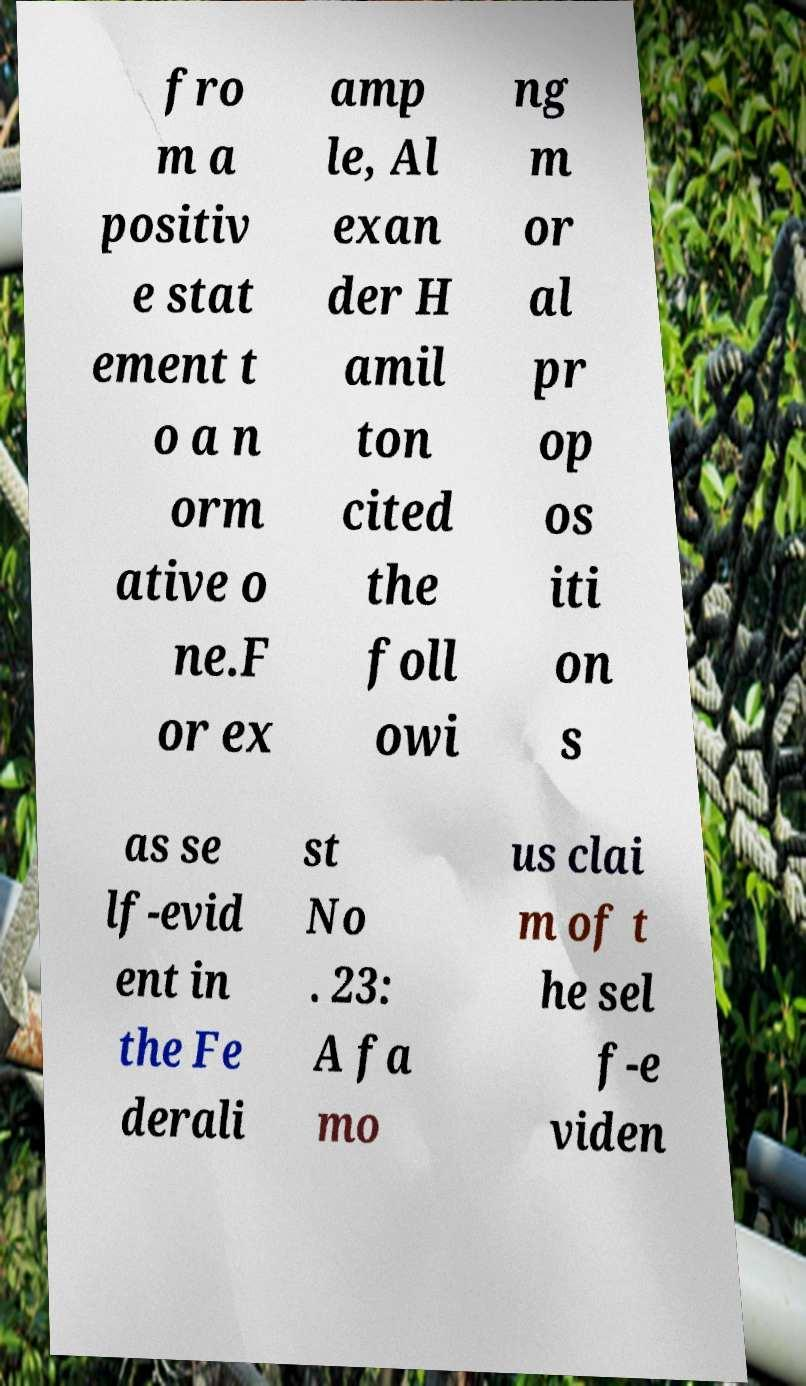Could you extract and type out the text from this image? fro m a positiv e stat ement t o a n orm ative o ne.F or ex amp le, Al exan der H amil ton cited the foll owi ng m or al pr op os iti on s as se lf-evid ent in the Fe derali st No . 23: A fa mo us clai m of t he sel f-e viden 